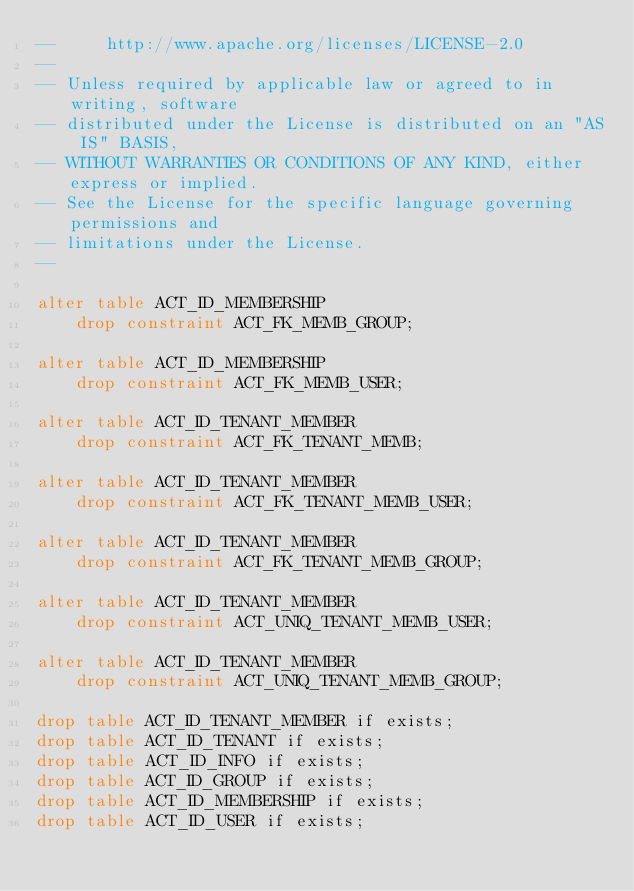Convert code to text. <code><loc_0><loc_0><loc_500><loc_500><_SQL_>--     http://www.apache.org/licenses/LICENSE-2.0
--
-- Unless required by applicable law or agreed to in writing, software
-- distributed under the License is distributed on an "AS IS" BASIS,
-- WITHOUT WARRANTIES OR CONDITIONS OF ANY KIND, either express or implied.
-- See the License for the specific language governing permissions and
-- limitations under the License.
--

alter table ACT_ID_MEMBERSHIP
    drop constraint ACT_FK_MEMB_GROUP;

alter table ACT_ID_MEMBERSHIP
    drop constraint ACT_FK_MEMB_USER;

alter table ACT_ID_TENANT_MEMBER
    drop constraint ACT_FK_TENANT_MEMB;

alter table ACT_ID_TENANT_MEMBER
    drop constraint ACT_FK_TENANT_MEMB_USER;

alter table ACT_ID_TENANT_MEMBER
    drop constraint ACT_FK_TENANT_MEMB_GROUP;

alter table ACT_ID_TENANT_MEMBER
    drop constraint ACT_UNIQ_TENANT_MEMB_USER;

alter table ACT_ID_TENANT_MEMBER
    drop constraint ACT_UNIQ_TENANT_MEMB_GROUP;

drop table ACT_ID_TENANT_MEMBER if exists;
drop table ACT_ID_TENANT if exists;
drop table ACT_ID_INFO if exists;
drop table ACT_ID_GROUP if exists;
drop table ACT_ID_MEMBERSHIP if exists;
drop table ACT_ID_USER if exists;
</code> 